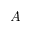Convert formula to latex. <formula><loc_0><loc_0><loc_500><loc_500>A</formula> 